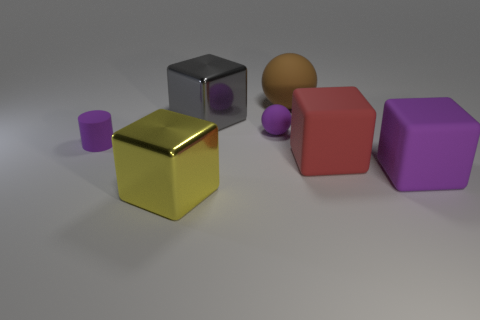If the objects in the image had weights proportional to their sizes, which object would be the heaviest? Assuming that all objects are made of materials with similar density, the red cube in the foreground would be the heaviest due to its larger overall size compared to the other objects. What could the different objects represent if this were a symbolic image? Symbolically, the objects might represent a variety of concepts. The cube could stand for stability and order, the sphere for completeness and unity, and the cylinder for strength and durability. The variety of shapes and colors could suggest diversity and the importance of different elements coming together to form a cohesive whole. 